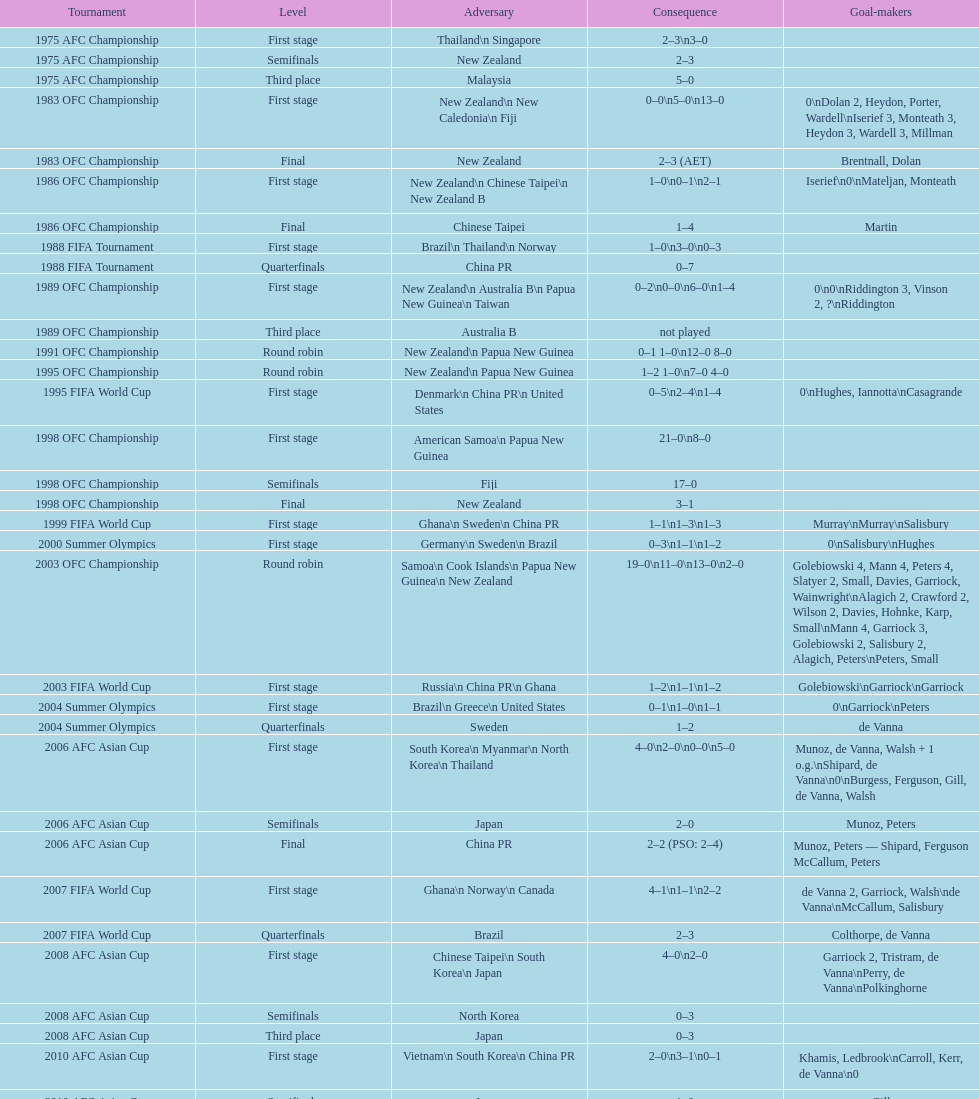What is the total number of competitions? 21. 